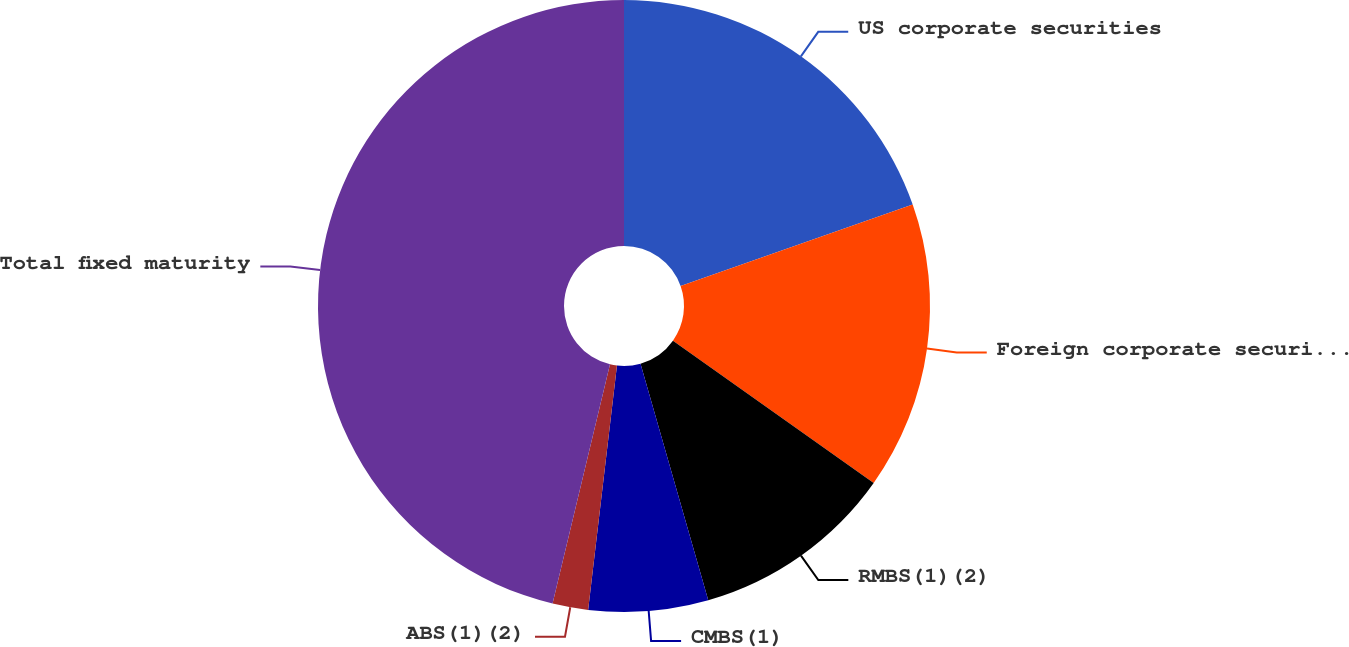Convert chart. <chart><loc_0><loc_0><loc_500><loc_500><pie_chart><fcel>US corporate securities<fcel>Foreign corporate securities<fcel>RMBS(1)(2)<fcel>CMBS(1)<fcel>ABS(1)(2)<fcel>Total fixed maturity<nl><fcel>19.62%<fcel>15.19%<fcel>10.75%<fcel>6.31%<fcel>1.88%<fcel>46.25%<nl></chart> 